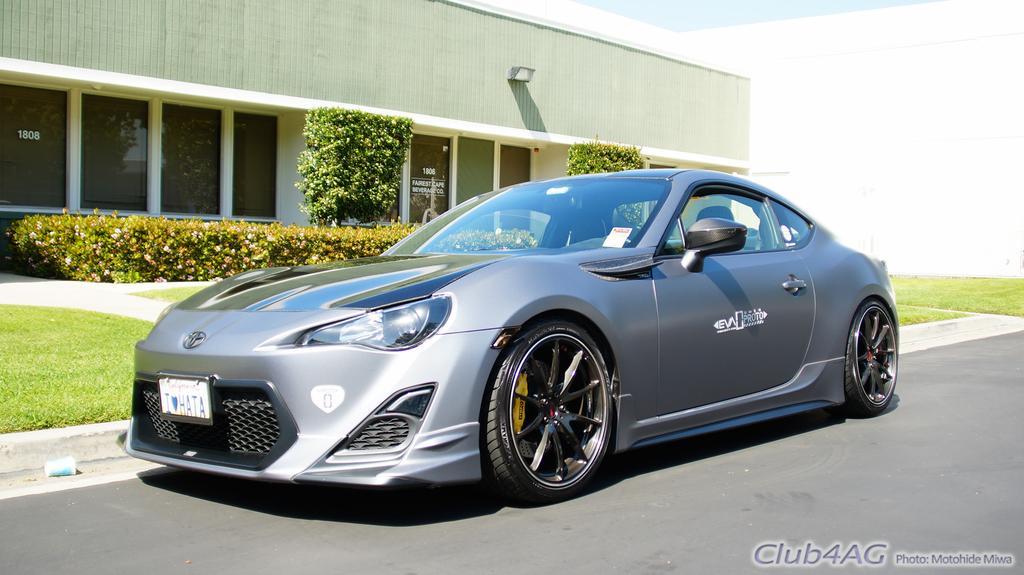In one or two sentences, can you explain what this image depicts? In the center of the image there is a car on the road. In the background we can see buildings, trees, plants and grass. In the background we can see building and sky. 